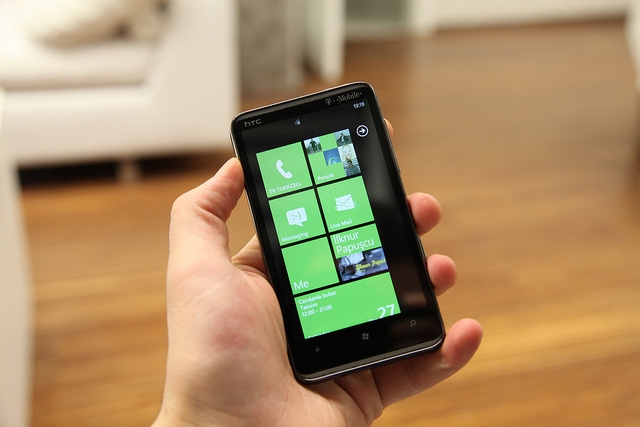Please transcribe the text in this image. htc 27 Me Papusuc 